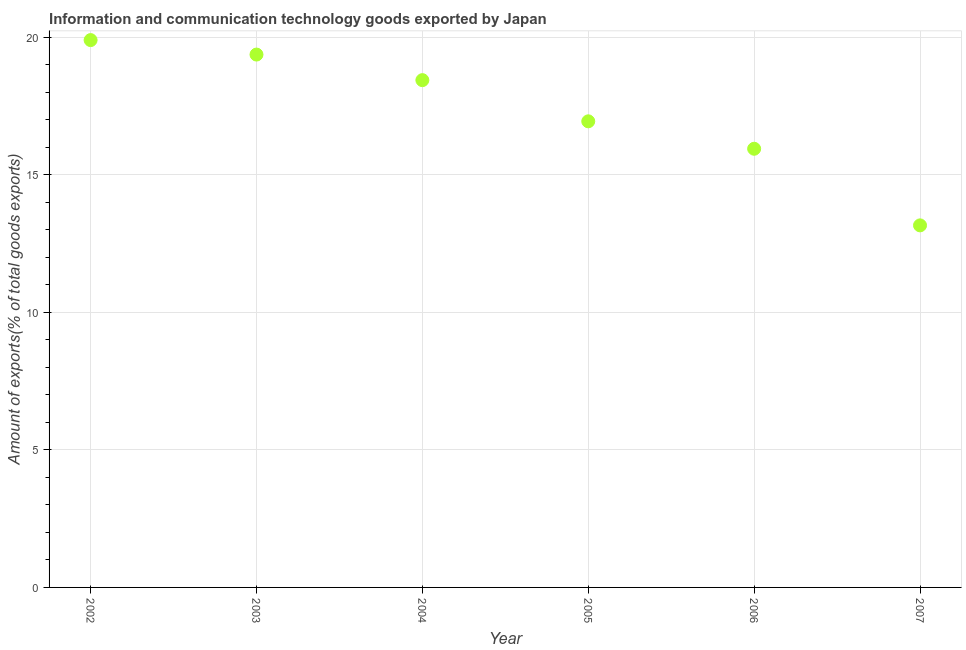What is the amount of ict goods exports in 2005?
Your response must be concise. 16.95. Across all years, what is the maximum amount of ict goods exports?
Make the answer very short. 19.9. Across all years, what is the minimum amount of ict goods exports?
Your answer should be very brief. 13.16. What is the sum of the amount of ict goods exports?
Provide a succinct answer. 103.77. What is the difference between the amount of ict goods exports in 2002 and 2004?
Ensure brevity in your answer.  1.46. What is the average amount of ict goods exports per year?
Make the answer very short. 17.29. What is the median amount of ict goods exports?
Ensure brevity in your answer.  17.69. Do a majority of the years between 2004 and 2003 (inclusive) have amount of ict goods exports greater than 17 %?
Ensure brevity in your answer.  No. What is the ratio of the amount of ict goods exports in 2003 to that in 2005?
Keep it short and to the point. 1.14. Is the amount of ict goods exports in 2004 less than that in 2007?
Your response must be concise. No. What is the difference between the highest and the second highest amount of ict goods exports?
Offer a terse response. 0.53. Is the sum of the amount of ict goods exports in 2005 and 2007 greater than the maximum amount of ict goods exports across all years?
Offer a very short reply. Yes. What is the difference between the highest and the lowest amount of ict goods exports?
Provide a succinct answer. 6.74. Does the amount of ict goods exports monotonically increase over the years?
Provide a succinct answer. No. How many dotlines are there?
Provide a succinct answer. 1. What is the difference between two consecutive major ticks on the Y-axis?
Keep it short and to the point. 5. Does the graph contain any zero values?
Your answer should be compact. No. Does the graph contain grids?
Make the answer very short. Yes. What is the title of the graph?
Offer a very short reply. Information and communication technology goods exported by Japan. What is the label or title of the Y-axis?
Your answer should be compact. Amount of exports(% of total goods exports). What is the Amount of exports(% of total goods exports) in 2002?
Give a very brief answer. 19.9. What is the Amount of exports(% of total goods exports) in 2003?
Offer a terse response. 19.37. What is the Amount of exports(% of total goods exports) in 2004?
Your answer should be compact. 18.44. What is the Amount of exports(% of total goods exports) in 2005?
Provide a succinct answer. 16.95. What is the Amount of exports(% of total goods exports) in 2006?
Your answer should be very brief. 15.95. What is the Amount of exports(% of total goods exports) in 2007?
Your answer should be compact. 13.16. What is the difference between the Amount of exports(% of total goods exports) in 2002 and 2003?
Make the answer very short. 0.53. What is the difference between the Amount of exports(% of total goods exports) in 2002 and 2004?
Make the answer very short. 1.46. What is the difference between the Amount of exports(% of total goods exports) in 2002 and 2005?
Offer a terse response. 2.95. What is the difference between the Amount of exports(% of total goods exports) in 2002 and 2006?
Your response must be concise. 3.95. What is the difference between the Amount of exports(% of total goods exports) in 2002 and 2007?
Keep it short and to the point. 6.74. What is the difference between the Amount of exports(% of total goods exports) in 2003 and 2004?
Offer a very short reply. 0.93. What is the difference between the Amount of exports(% of total goods exports) in 2003 and 2005?
Offer a terse response. 2.43. What is the difference between the Amount of exports(% of total goods exports) in 2003 and 2006?
Provide a short and direct response. 3.42. What is the difference between the Amount of exports(% of total goods exports) in 2003 and 2007?
Your response must be concise. 6.21. What is the difference between the Amount of exports(% of total goods exports) in 2004 and 2005?
Keep it short and to the point. 1.5. What is the difference between the Amount of exports(% of total goods exports) in 2004 and 2006?
Ensure brevity in your answer.  2.49. What is the difference between the Amount of exports(% of total goods exports) in 2004 and 2007?
Provide a succinct answer. 5.28. What is the difference between the Amount of exports(% of total goods exports) in 2005 and 2006?
Provide a short and direct response. 1. What is the difference between the Amount of exports(% of total goods exports) in 2005 and 2007?
Keep it short and to the point. 3.78. What is the difference between the Amount of exports(% of total goods exports) in 2006 and 2007?
Make the answer very short. 2.79. What is the ratio of the Amount of exports(% of total goods exports) in 2002 to that in 2003?
Provide a succinct answer. 1.03. What is the ratio of the Amount of exports(% of total goods exports) in 2002 to that in 2004?
Provide a short and direct response. 1.08. What is the ratio of the Amount of exports(% of total goods exports) in 2002 to that in 2005?
Make the answer very short. 1.17. What is the ratio of the Amount of exports(% of total goods exports) in 2002 to that in 2006?
Offer a very short reply. 1.25. What is the ratio of the Amount of exports(% of total goods exports) in 2002 to that in 2007?
Your answer should be very brief. 1.51. What is the ratio of the Amount of exports(% of total goods exports) in 2003 to that in 2004?
Provide a short and direct response. 1.05. What is the ratio of the Amount of exports(% of total goods exports) in 2003 to that in 2005?
Your answer should be compact. 1.14. What is the ratio of the Amount of exports(% of total goods exports) in 2003 to that in 2006?
Offer a terse response. 1.22. What is the ratio of the Amount of exports(% of total goods exports) in 2003 to that in 2007?
Your response must be concise. 1.47. What is the ratio of the Amount of exports(% of total goods exports) in 2004 to that in 2005?
Your response must be concise. 1.09. What is the ratio of the Amount of exports(% of total goods exports) in 2004 to that in 2006?
Provide a short and direct response. 1.16. What is the ratio of the Amount of exports(% of total goods exports) in 2004 to that in 2007?
Make the answer very short. 1.4. What is the ratio of the Amount of exports(% of total goods exports) in 2005 to that in 2006?
Give a very brief answer. 1.06. What is the ratio of the Amount of exports(% of total goods exports) in 2005 to that in 2007?
Your answer should be compact. 1.29. What is the ratio of the Amount of exports(% of total goods exports) in 2006 to that in 2007?
Your answer should be very brief. 1.21. 